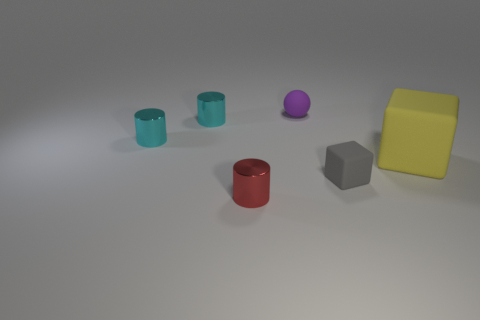What shape is the large thing that is the same material as the tiny cube?
Ensure brevity in your answer.  Cube. How many matte objects are either purple balls or cyan things?
Give a very brief answer. 1. There is a small cylinder that is in front of the small rubber object that is right of the tiny purple thing; how many yellow matte things are to the left of it?
Offer a very short reply. 0. Is the size of the cylinder that is in front of the large matte cube the same as the matte cube behind the tiny gray cube?
Ensure brevity in your answer.  No. What material is the other small thing that is the same shape as the yellow matte object?
Make the answer very short. Rubber. What number of large objects are cyan metallic spheres or gray rubber blocks?
Provide a short and direct response. 0. What is the purple thing made of?
Your response must be concise. Rubber. There is a thing that is both left of the purple ball and in front of the large yellow matte object; what is it made of?
Your answer should be compact. Metal. Is the color of the big matte object the same as the small cylinder in front of the big yellow rubber thing?
Give a very brief answer. No. There is a purple object that is the same size as the red metal object; what is it made of?
Keep it short and to the point. Rubber. 